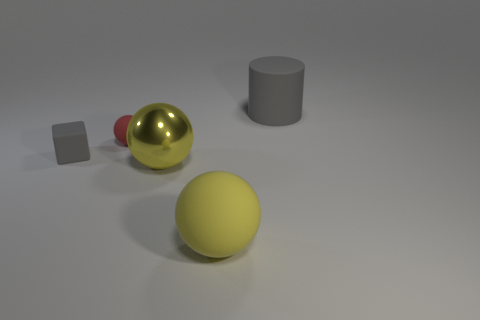Subtract all red spheres. How many spheres are left? 2 Subtract all red balls. How many balls are left? 2 Add 1 small brown metal cylinders. How many objects exist? 6 Subtract all cylinders. How many objects are left? 4 Subtract 1 blocks. How many blocks are left? 0 Add 5 tiny rubber objects. How many tiny rubber objects are left? 7 Add 4 small matte blocks. How many small matte blocks exist? 5 Subtract 1 red spheres. How many objects are left? 4 Subtract all brown blocks. Subtract all blue spheres. How many blocks are left? 1 Subtract all purple cylinders. How many yellow spheres are left? 2 